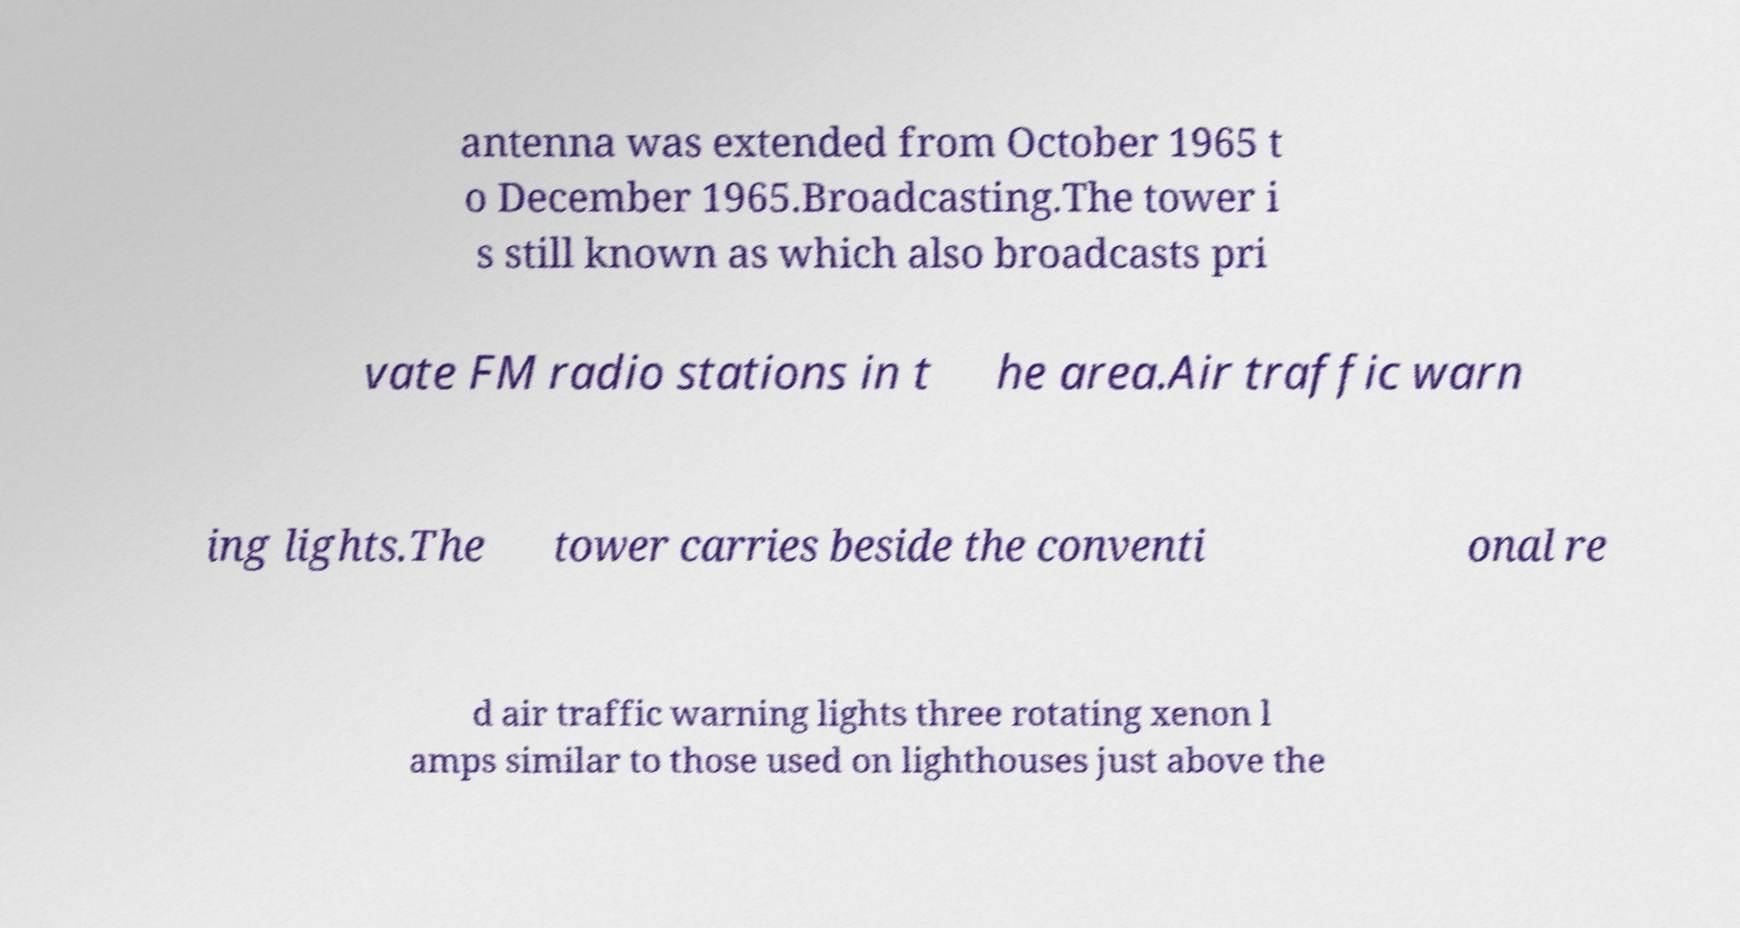Can you read and provide the text displayed in the image?This photo seems to have some interesting text. Can you extract and type it out for me? antenna was extended from October 1965 t o December 1965.Broadcasting.The tower i s still known as which also broadcasts pri vate FM radio stations in t he area.Air traffic warn ing lights.The tower carries beside the conventi onal re d air traffic warning lights three rotating xenon l amps similar to those used on lighthouses just above the 